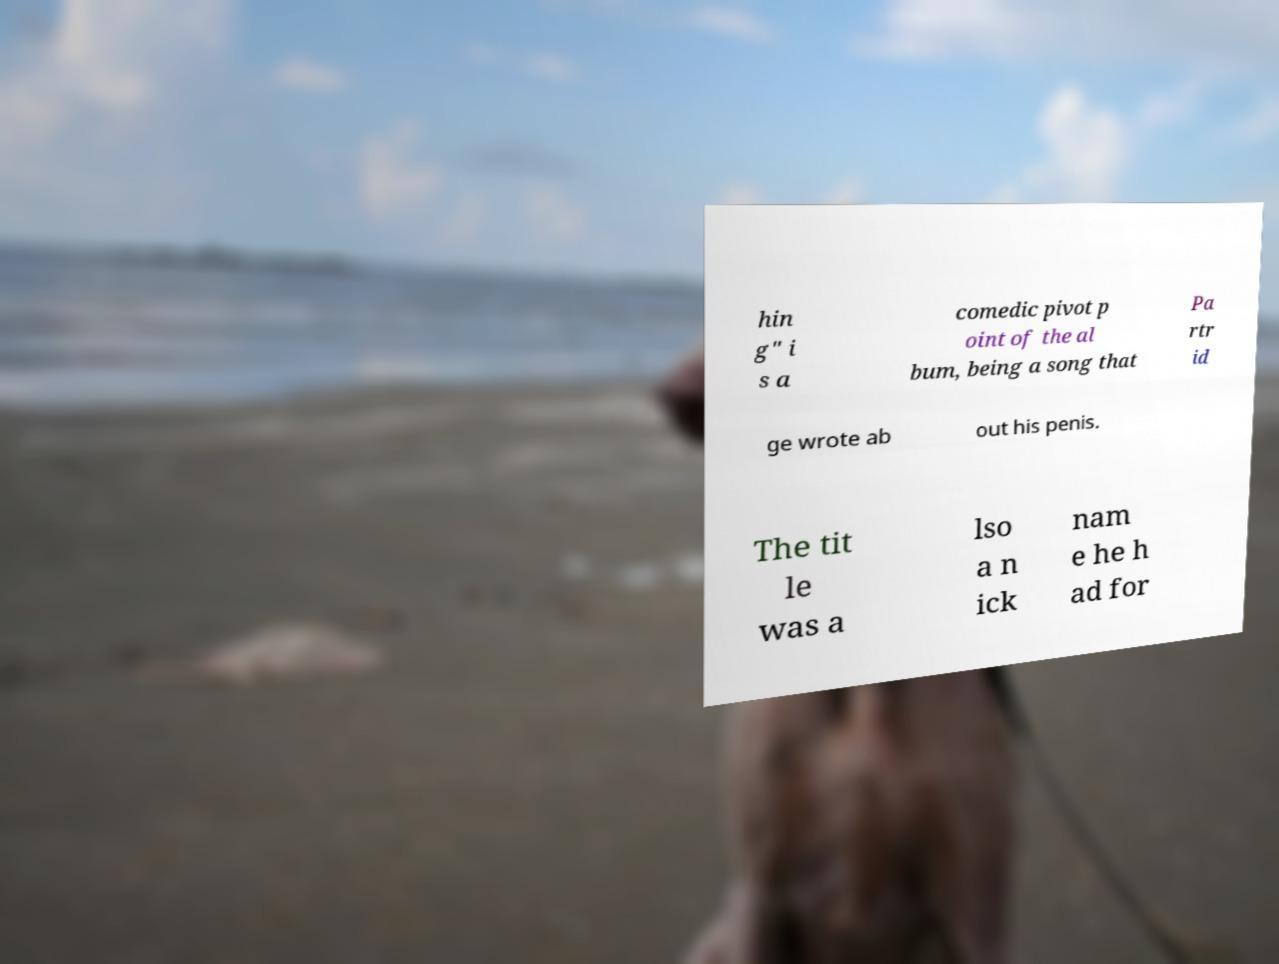Please identify and transcribe the text found in this image. hin g" i s a comedic pivot p oint of the al bum, being a song that Pa rtr id ge wrote ab out his penis. The tit le was a lso a n ick nam e he h ad for 